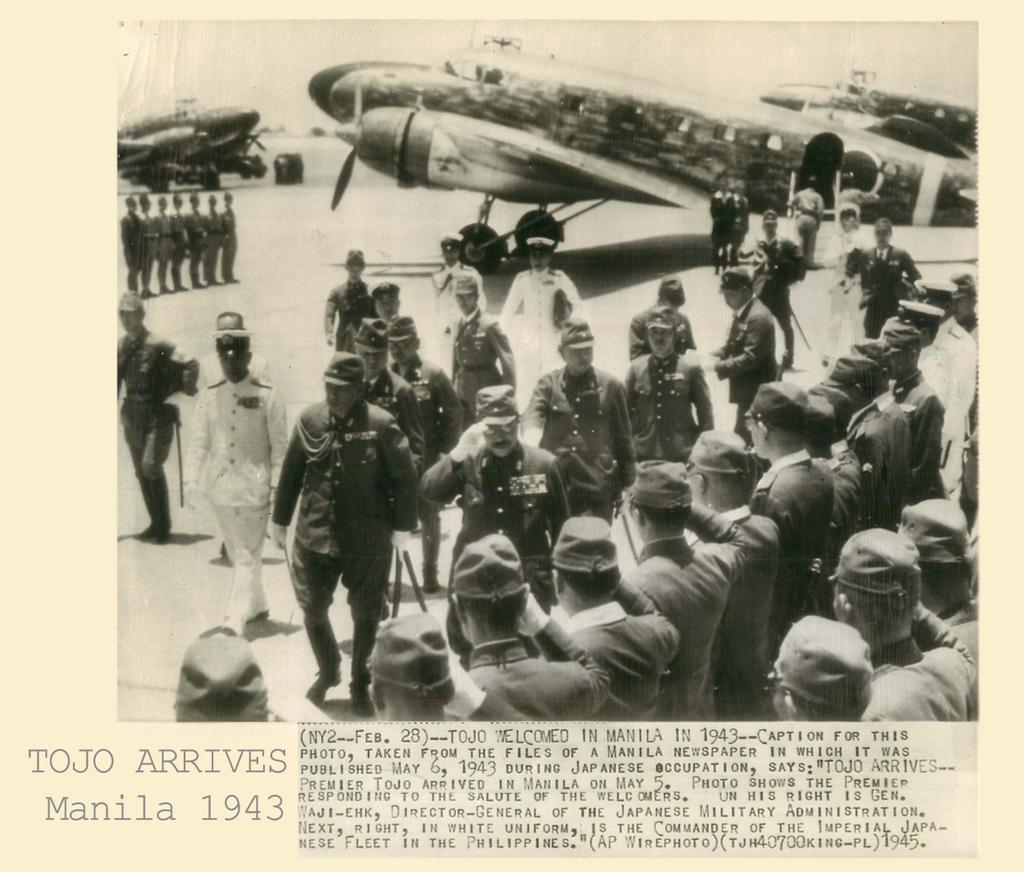In one or two sentences, can you explain what this image depicts? In the foreground I can see a crowd on the ground. On the top I can see an aircraft. This image is taken during a day on the road. 